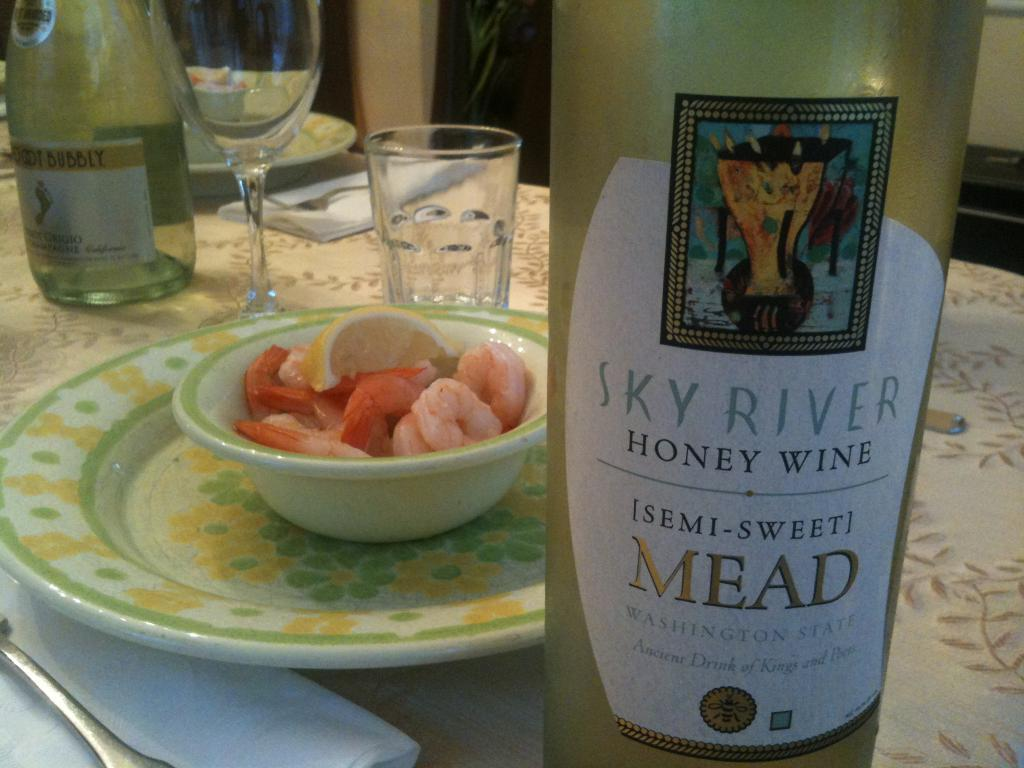<image>
Render a clear and concise summary of the photo. Yellow bottle of honey wine next to a bowl of shrimp. 